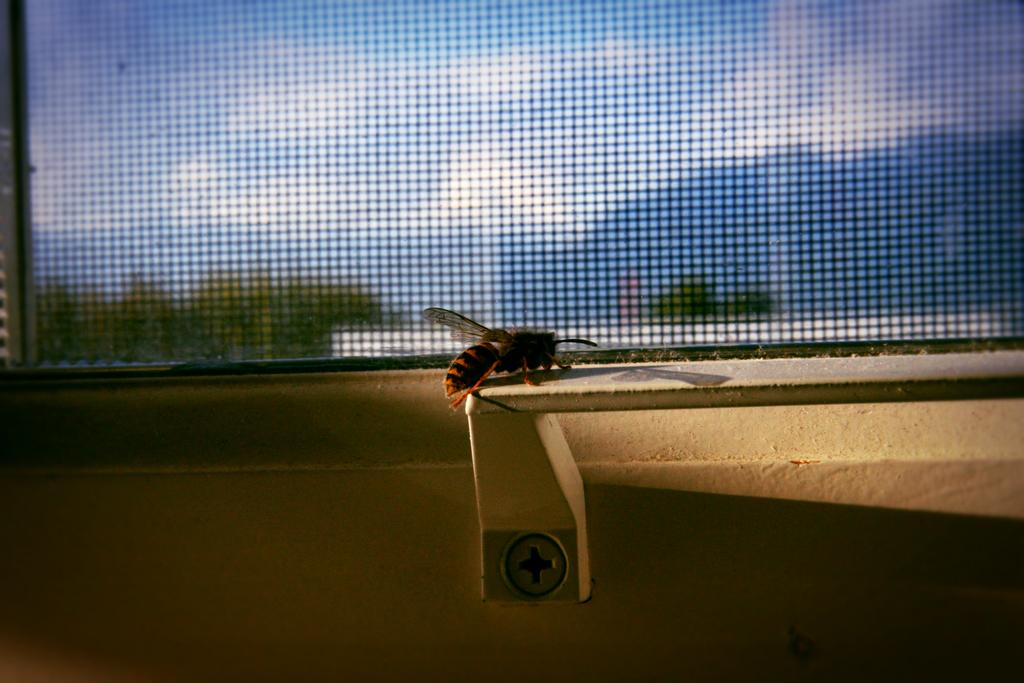What type of creature can be seen in the image? There is an insect in the image. What is the background of the image? There is a wall in the image. What can be seen through the window in the image? The sky and trees are visible outside the window. What type of manager is responsible for the insect in the image? There is no manager present in the image, as it features an insect and various elements of a room or outdoor setting. 